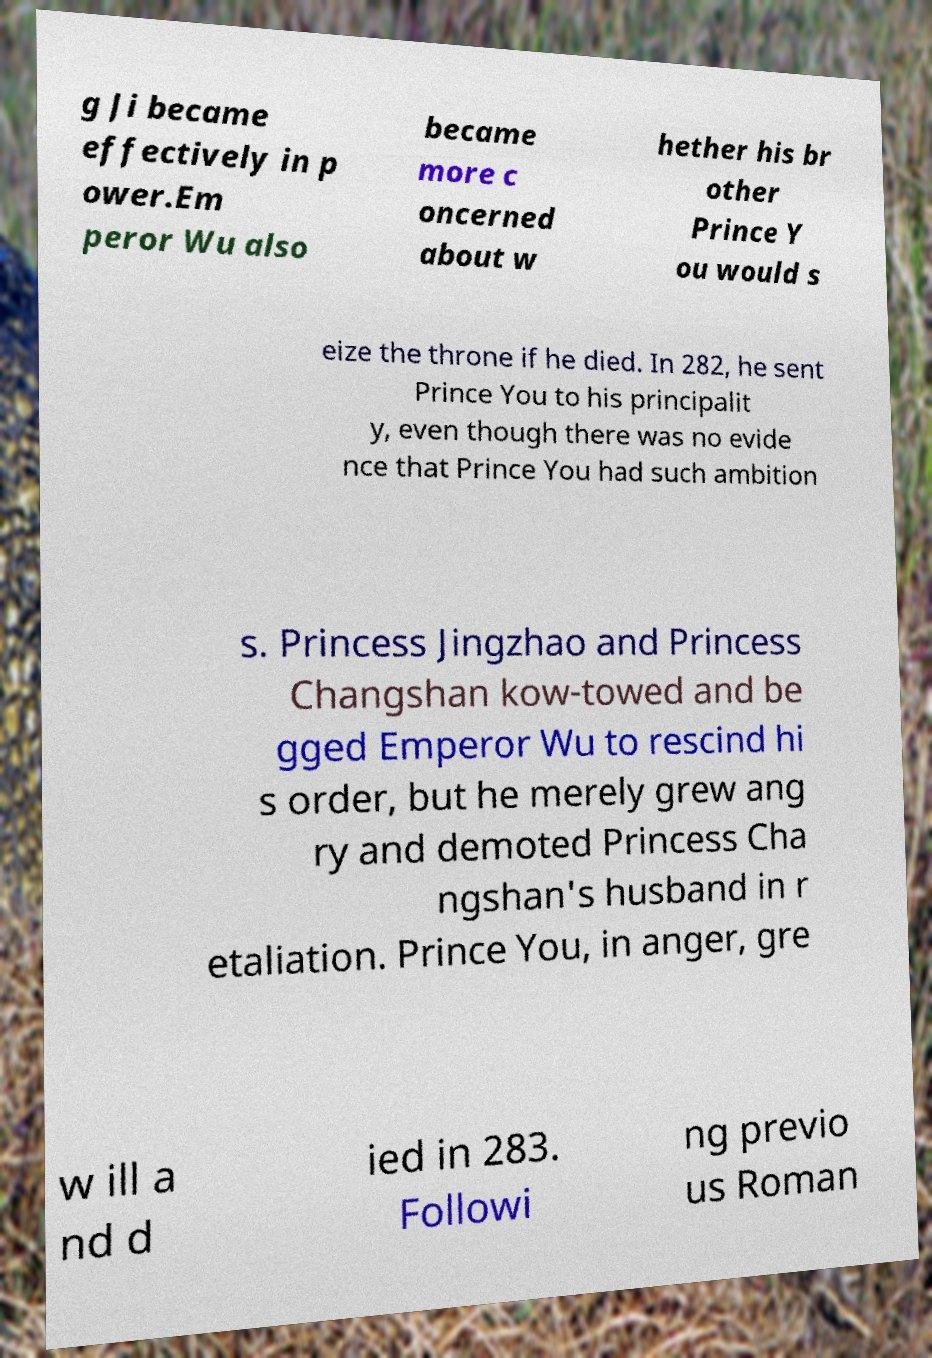What messages or text are displayed in this image? I need them in a readable, typed format. g Ji became effectively in p ower.Em peror Wu also became more c oncerned about w hether his br other Prince Y ou would s eize the throne if he died. In 282, he sent Prince You to his principalit y, even though there was no evide nce that Prince You had such ambition s. Princess Jingzhao and Princess Changshan kow-towed and be gged Emperor Wu to rescind hi s order, but he merely grew ang ry and demoted Princess Cha ngshan's husband in r etaliation. Prince You, in anger, gre w ill a nd d ied in 283. Followi ng previo us Roman 